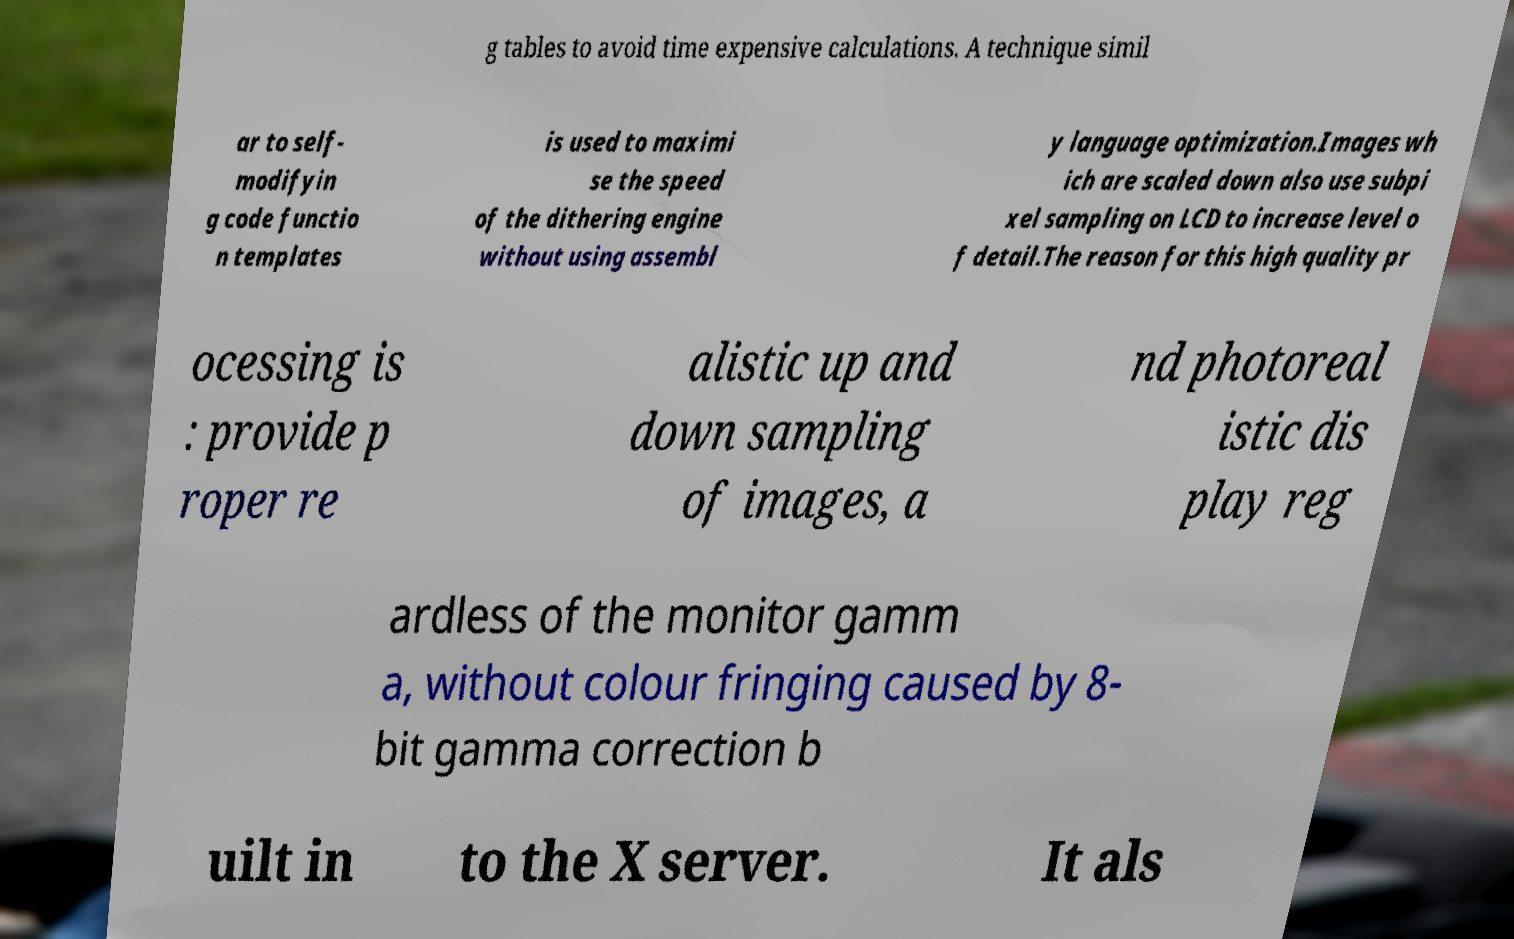Could you extract and type out the text from this image? g tables to avoid time expensive calculations. A technique simil ar to self- modifyin g code functio n templates is used to maximi se the speed of the dithering engine without using assembl y language optimization.Images wh ich are scaled down also use subpi xel sampling on LCD to increase level o f detail.The reason for this high quality pr ocessing is : provide p roper re alistic up and down sampling of images, a nd photoreal istic dis play reg ardless of the monitor gamm a, without colour fringing caused by 8- bit gamma correction b uilt in to the X server. It als 